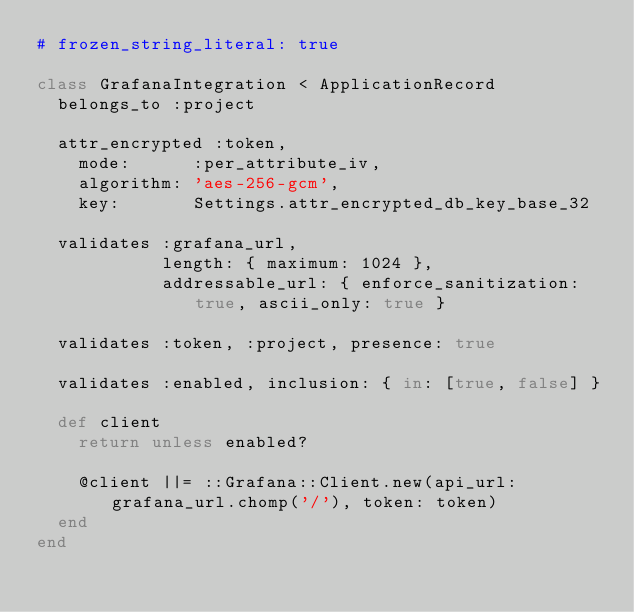Convert code to text. <code><loc_0><loc_0><loc_500><loc_500><_Ruby_># frozen_string_literal: true

class GrafanaIntegration < ApplicationRecord
  belongs_to :project

  attr_encrypted :token,
    mode:      :per_attribute_iv,
    algorithm: 'aes-256-gcm',
    key:       Settings.attr_encrypted_db_key_base_32

  validates :grafana_url,
            length: { maximum: 1024 },
            addressable_url: { enforce_sanitization: true, ascii_only: true }

  validates :token, :project, presence: true

  validates :enabled, inclusion: { in: [true, false] }

  def client
    return unless enabled?

    @client ||= ::Grafana::Client.new(api_url: grafana_url.chomp('/'), token: token)
  end
end
</code> 